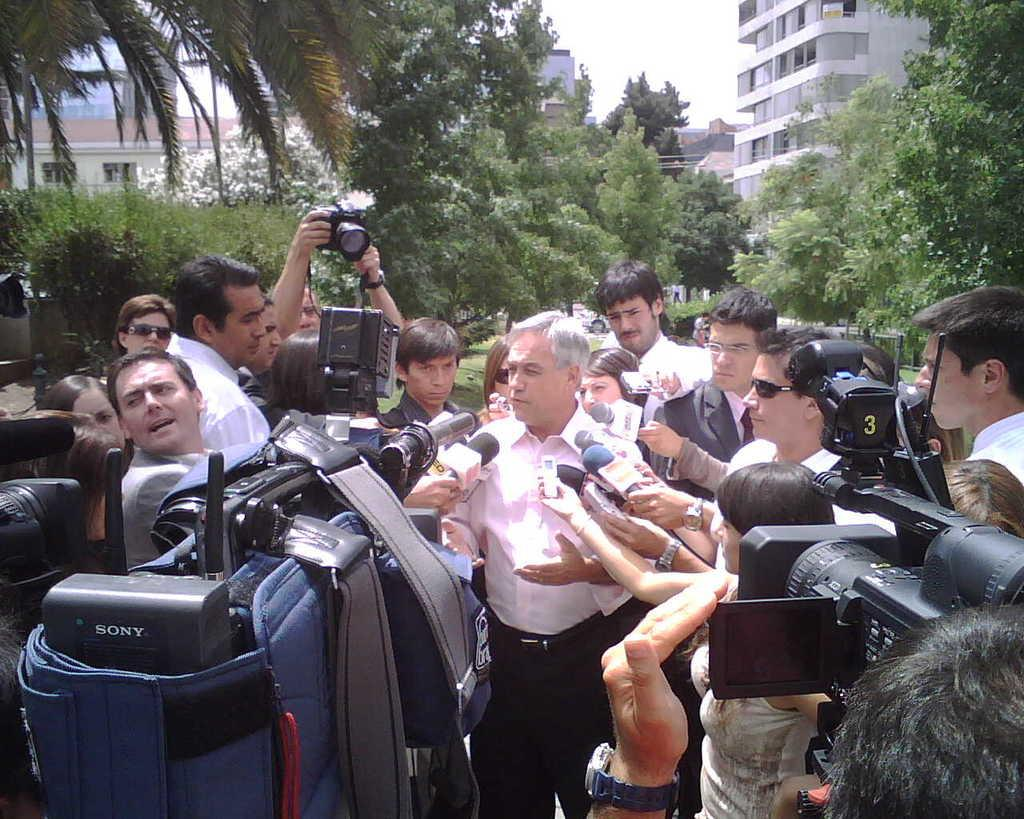How many people are in the image? There is a group of people in the image, but the exact number is not specified. What are some of the people holding in the image? Some of the people are holding cameras and microphones. What type of structures can be seen in the image? There are buildings in the image. What other natural elements are present in the image? There are trees in the image. What part of the natural environment is visible in the image? The sky is visible in the image. What type of school can be seen in the image? There is no school present in the image. Is there a volleyball game taking place in the image? There is no volleyball game or any reference to sports in the image. What advertisement is being displayed on the buildings in the image? There is no advertisement visible on the buildings in the image. 